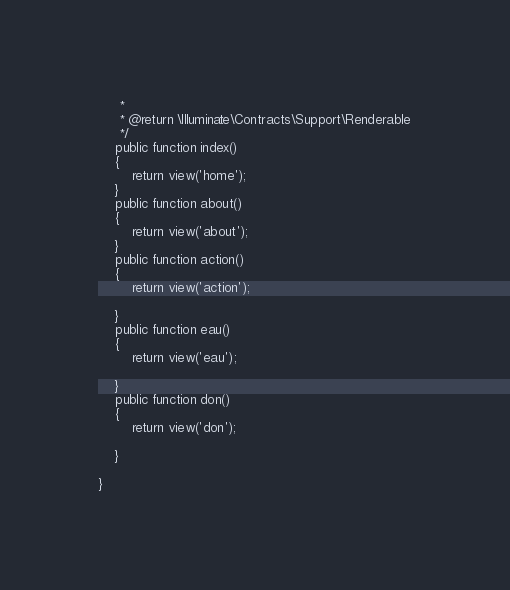Convert code to text. <code><loc_0><loc_0><loc_500><loc_500><_PHP_>     *
     * @return \Illuminate\Contracts\Support\Renderable
     */
    public function index()
    {
        return view('home');
    }
    public function about()
    {
        return view('about');
    }
    public function action()
    {
        return view('action');
        
    }
    public function eau()
    {
        return view('eau');
        
    }
    public function don()
    {
        return view('don');
        
    }
   
}
</code> 